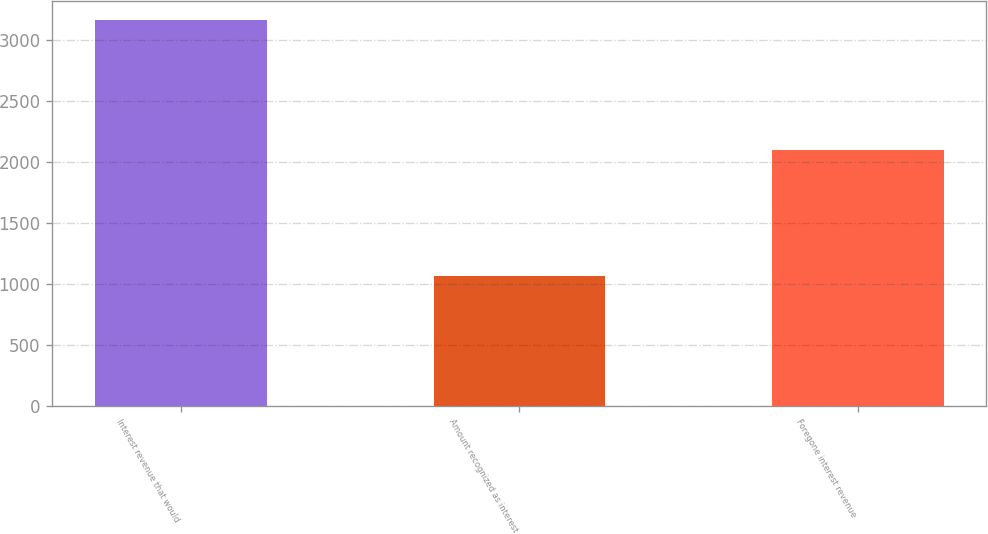Convert chart. <chart><loc_0><loc_0><loc_500><loc_500><bar_chart><fcel>Interest revenue that would<fcel>Amount recognized as interest<fcel>Foregone interest revenue<nl><fcel>3159<fcel>1064<fcel>2095<nl></chart> 